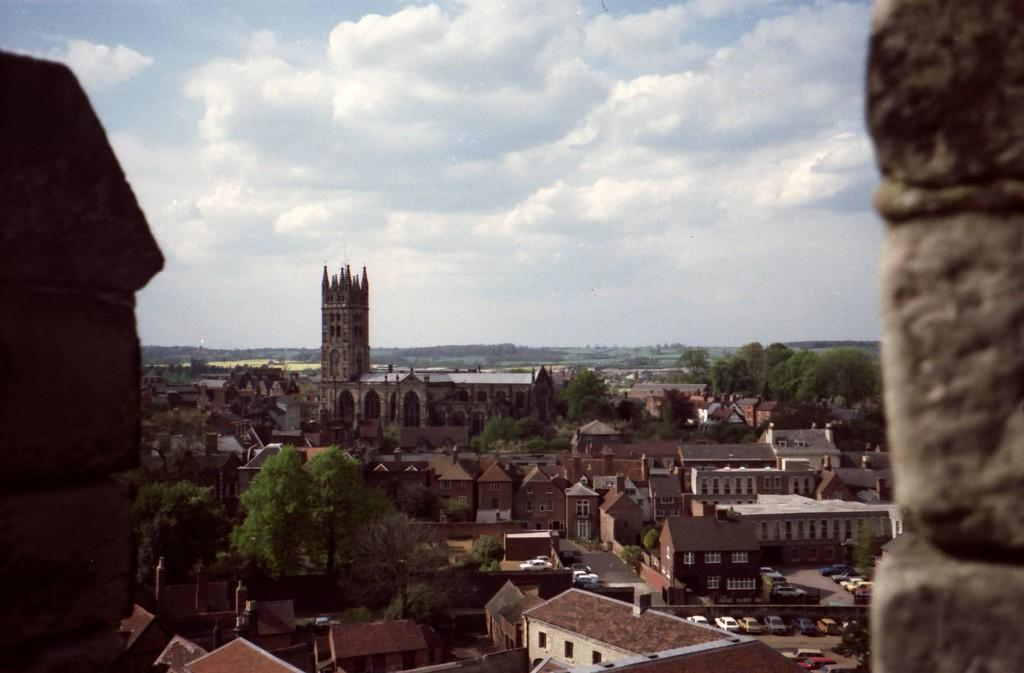What can be seen in the sky in the background of the image? There are clouds in the sky in the background of the image. What type of natural elements are present in the image? There are trees in the image. What type of man-made structures are present in the image? There are buildings, a rooftop, and a tower in the image. What type of infrastructure is present in the image? There is a road in the image. What type of transportation is present in the image? There are vehicles in the image. What type of engine can be seen powering the yam in the image? There is no yam or engine present in the image. What type of collar is visible on the tower in the image? There is no collar present on the tower in the image. 